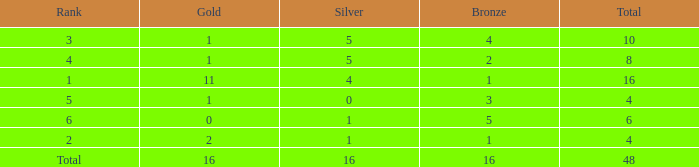What is the total gold that has bronze less than 2, a silver of 1 and total more than 4? None. 